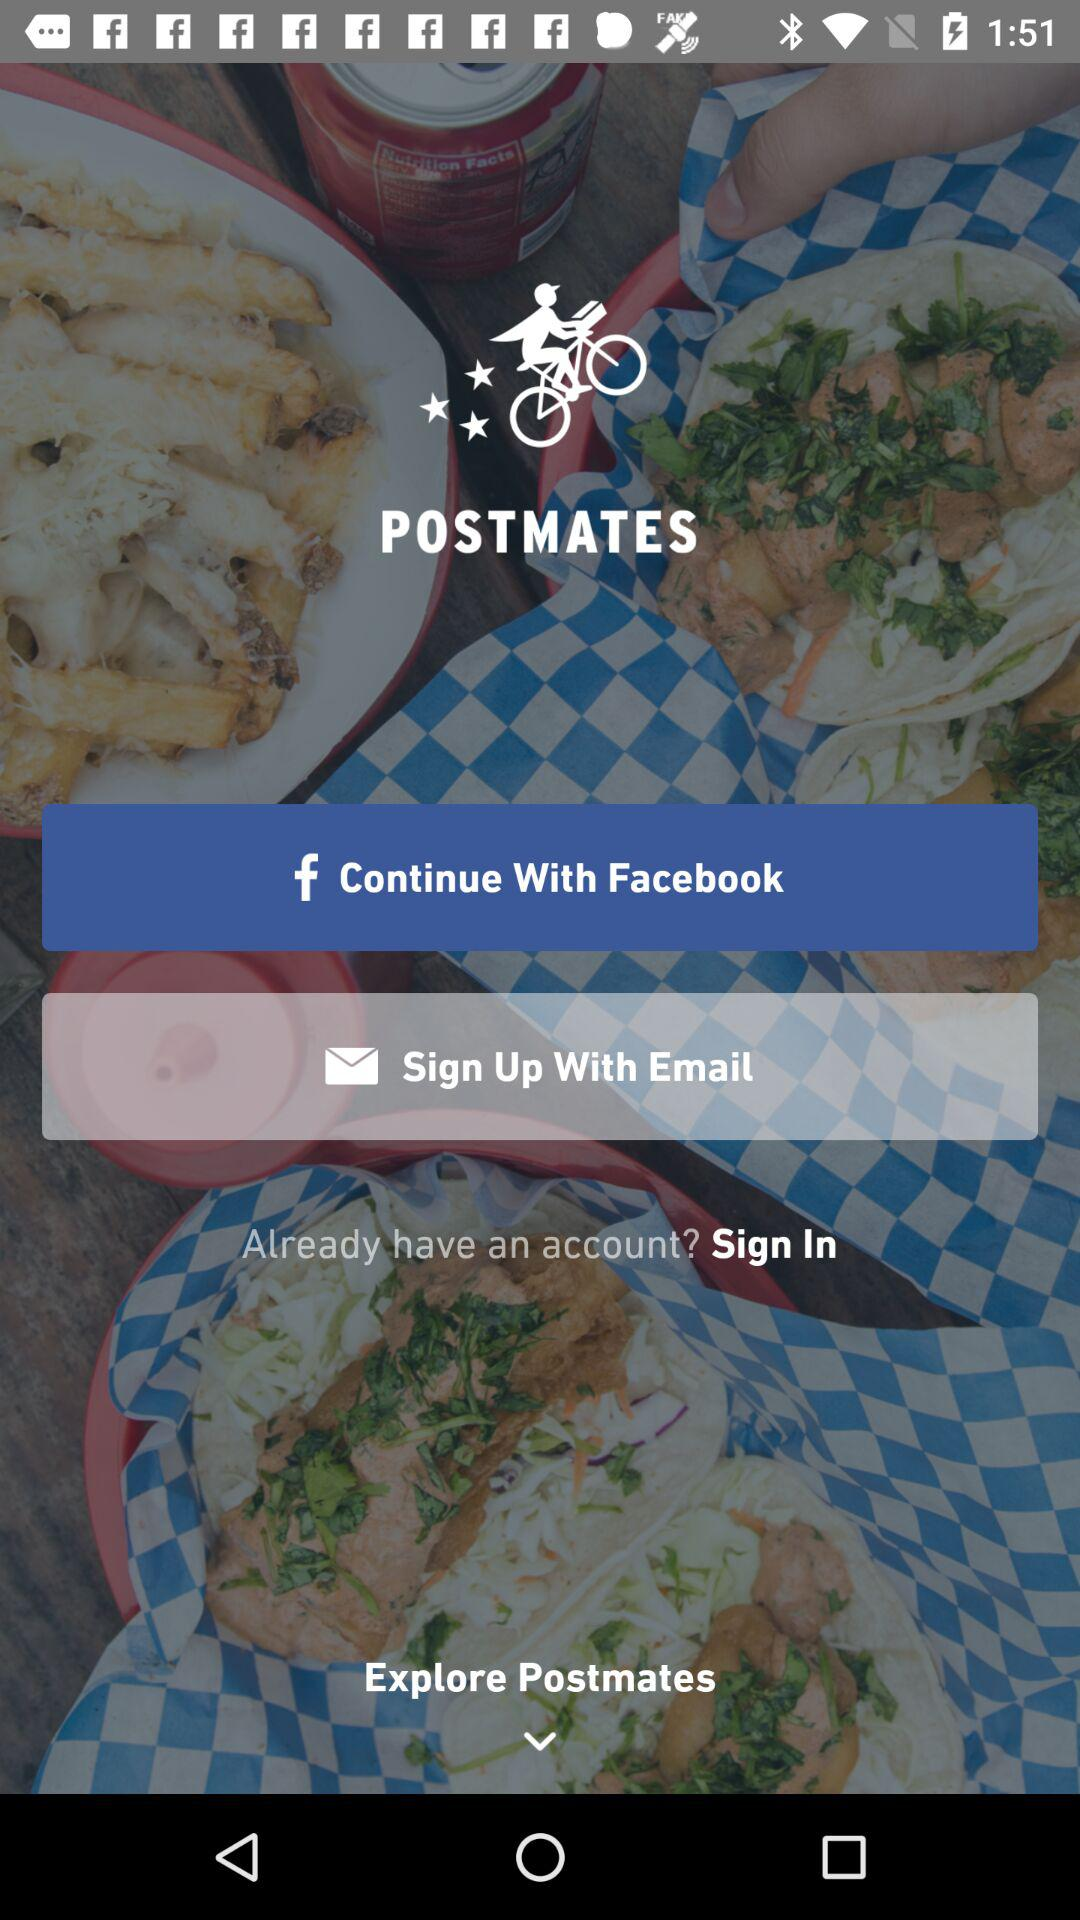Through which account can sign-up be done? Sign-up can be done through "Facebook" and "Email". 